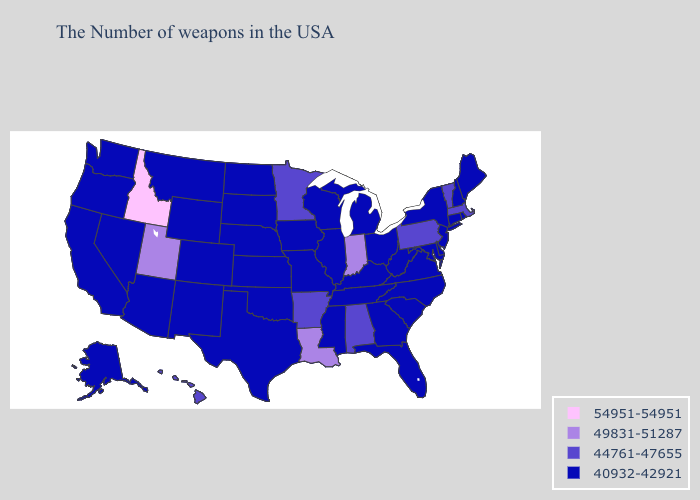Among the states that border Delaware , which have the highest value?
Concise answer only. Pennsylvania. Name the states that have a value in the range 44761-47655?
Quick response, please. Massachusetts, Vermont, Pennsylvania, Alabama, Arkansas, Minnesota, Hawaii. Name the states that have a value in the range 49831-51287?
Give a very brief answer. Indiana, Louisiana, Utah. What is the value of Nebraska?
Keep it brief. 40932-42921. Name the states that have a value in the range 54951-54951?
Answer briefly. Idaho. Does South Dakota have the highest value in the MidWest?
Write a very short answer. No. Does Vermont have the lowest value in the USA?
Short answer required. No. Name the states that have a value in the range 54951-54951?
Be succinct. Idaho. Does Florida have the lowest value in the USA?
Quick response, please. Yes. What is the value of Louisiana?
Quick response, please. 49831-51287. Which states have the lowest value in the Northeast?
Answer briefly. Maine, Rhode Island, New Hampshire, Connecticut, New York, New Jersey. What is the highest value in the USA?
Keep it brief. 54951-54951. Is the legend a continuous bar?
Be succinct. No. 